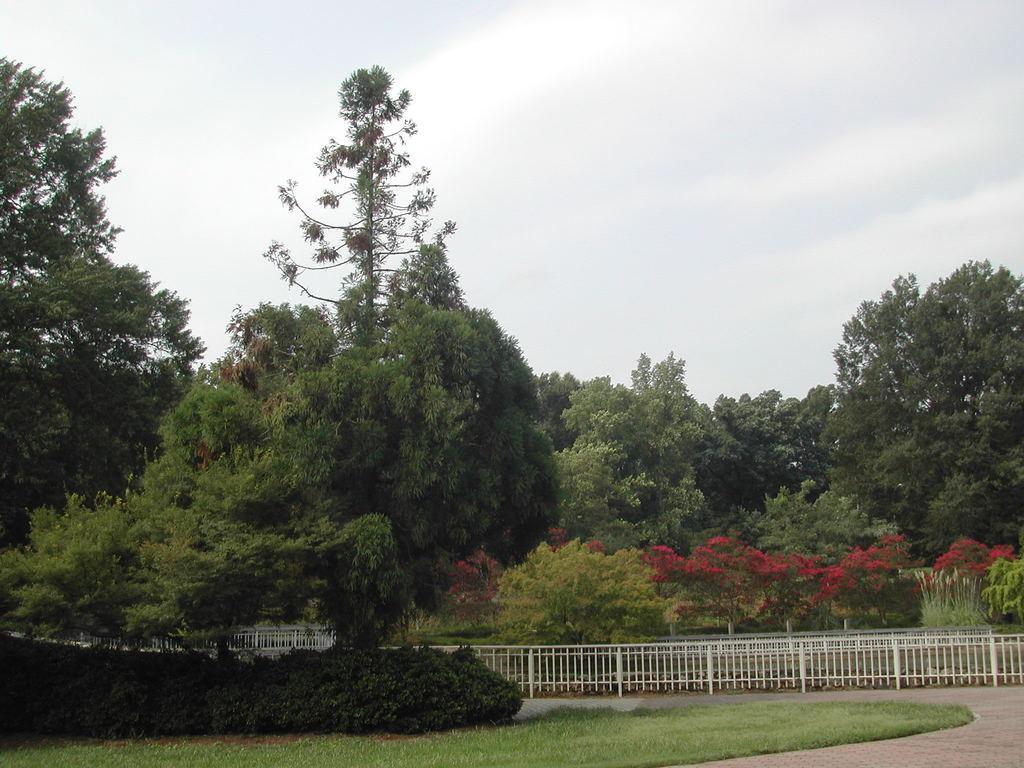Can you describe this image briefly? This picture is taken from outside of the city. In this image, we can see some trees, plants, metal rod, metal grill. At the top, we can see a sky which is cloudy, at the bottom, we can see a grass and a land. 